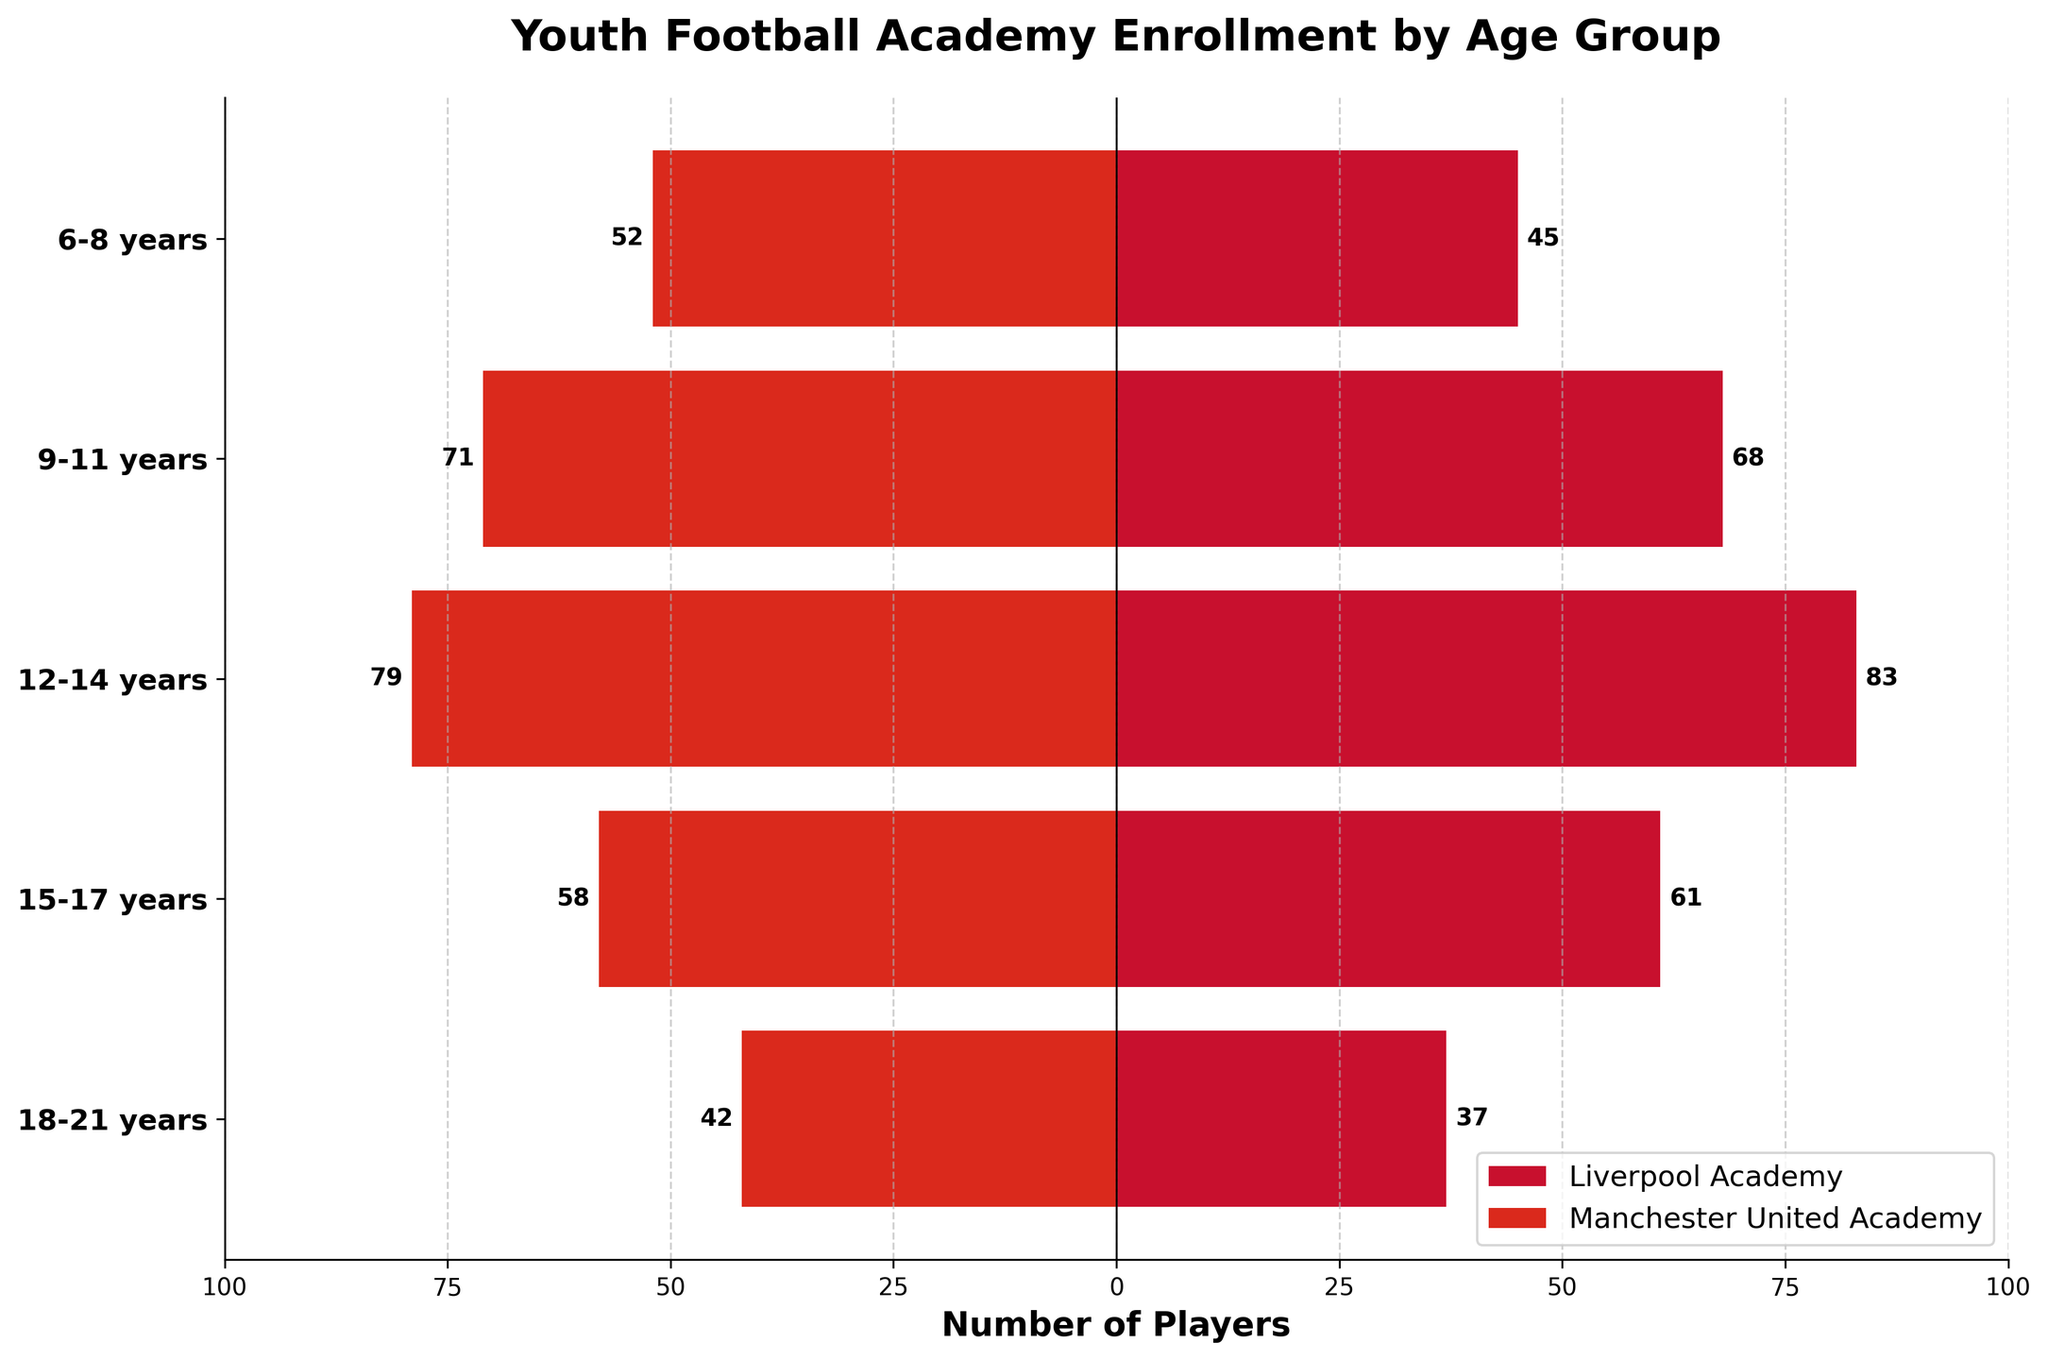What is the title of the figure? The title of the figure is usually found at the top. It gives a very brief summary of what the plot is about, in this case, showing the enrollment numbers by age group for Liverpool and Manchester United academies.
Answer: Youth Football Academy Enrollment by Age Group What does the x-axis represent? The x-axis, which runs horizontally, represents the number of players enrolled in each academy for the corresponding age groups. Positive values are for Liverpool, and negative values are for Manchester United.
Answer: Number of Players Which academy has higher enrollment in the 6-8 years age group? By looking at the bars for the 6-8 years age group, compare the lengths of the positive (Liverpool) and negative (Manchester United) bars. The longer bar indicates a higher enrollment.
Answer: Manchester United What is the enrollment difference between Liverpool and Manchester United in the 15-17 years age group? Find the number of players for both academies in the 15-17 years age group and calculate the absolute difference. Liverpool has 61 players and Manchester United has 58, so the difference is 61 - 58.
Answer: 3 Which age group has the highest enrollment for Liverpool Academy? Look for the longest positive bar corresponding to Liverpool Academy. Compare all age groups and identify the one with the longest bar.
Answer: 12-14 years What is the combined total enrollment for 12-14 years and 15-17 years age groups for Manchester United Academy? Identify the number of players for Manchester United in both age groups and sum them up. For 12-14 years, it is 79 and for 15-17 years, it is 58, yielding a total of 79 + 58.
Answer: 137 Which age group shows the largest difference in enrollment numbers between the two academies? For each age group, calculate the absolute difference in enrollment numbers between Liverpool and Manchester United, then identify the age group with the largest difference.
Answer: 6-8 years What is the average enrollment for Liverpool Academy players across all age groups? Sum up the enrollment numbers for Liverpool across all age groups, then divide by the number of age groups (5). The sum is 45 + 68 + 83 + 61 + 37 = 294, and the average is 294 / 5.
Answer: 58.8 In the 18-21 years age group, how many more players does Manchester United have compared to Liverpool? Identify the enrollment for both academies in the 18-21 years age group, then subtract Liverpool’s number from Manchester United’s number. Manchester United has 42, Liverpool has 37.
Answer: 5 Which academy has more total players in all age groups combined? Sum up the enrollment numbers for each academy across all age groups; Liverpool's total is 294 and Manchester United's total is 302. Compare the two totals to determine which is larger.
Answer: Manchester United 